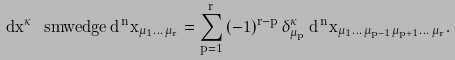<formula> <loc_0><loc_0><loc_500><loc_500>d x ^ { \kappa } \, \ s m w e d g e \, d ^ { \, n } x _ { \mu _ { 1 } \dots \, \mu _ { r } } = \sum _ { p = 1 } ^ { r } \, ( - 1 ) ^ { r - p } \, \delta _ { \mu _ { p } } ^ { \kappa } \, d ^ { \, n } x _ { \mu _ { 1 } \dots \, \mu _ { p - 1 } \mu _ { p + 1 } \dots \, \mu _ { r } } .</formula> 